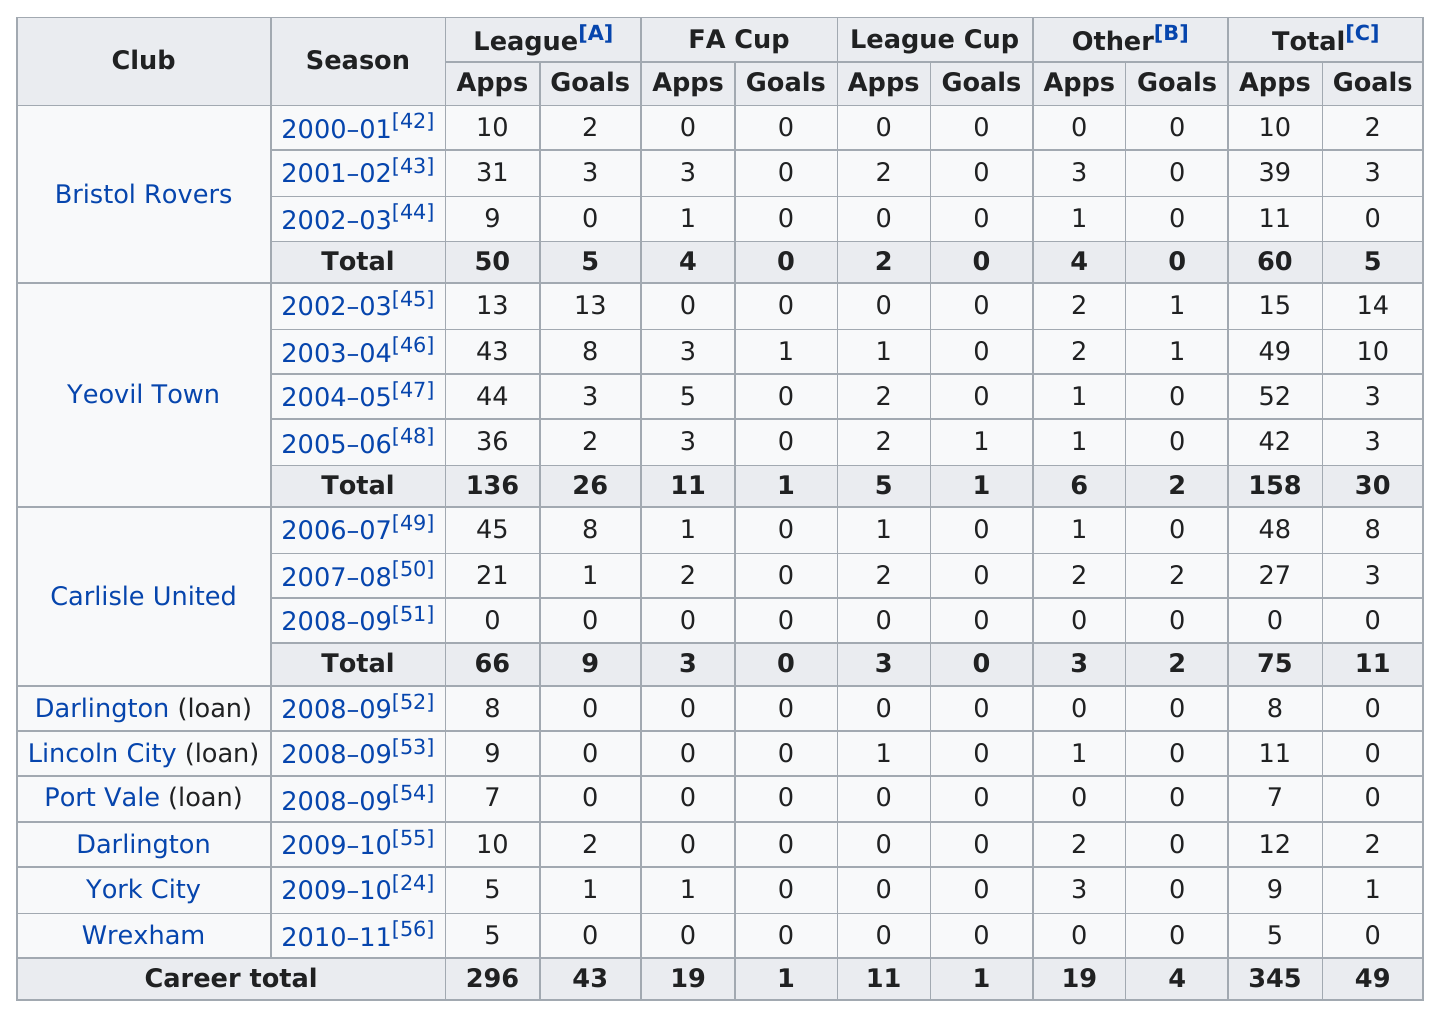Indicate a few pertinent items in this graphic. Kevin Gall played for Yeovil Town for a total of 4 seasons. Kevin Gall scored the most goals for Yeovil Town. GALL, a former player for Carlisle United, played for the team for a total of 3 years. 